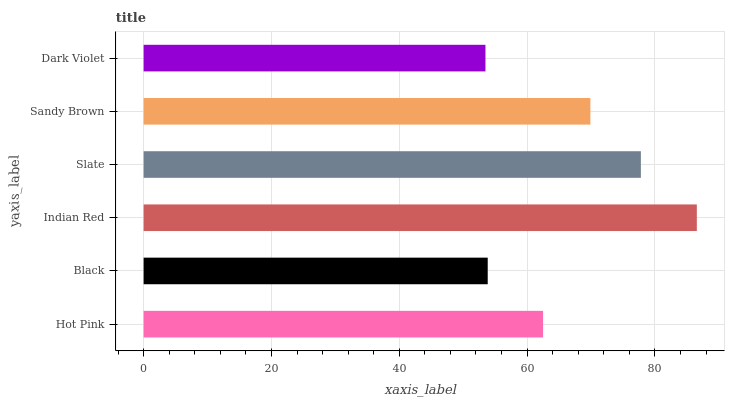Is Dark Violet the minimum?
Answer yes or no. Yes. Is Indian Red the maximum?
Answer yes or no. Yes. Is Black the minimum?
Answer yes or no. No. Is Black the maximum?
Answer yes or no. No. Is Hot Pink greater than Black?
Answer yes or no. Yes. Is Black less than Hot Pink?
Answer yes or no. Yes. Is Black greater than Hot Pink?
Answer yes or no. No. Is Hot Pink less than Black?
Answer yes or no. No. Is Sandy Brown the high median?
Answer yes or no. Yes. Is Hot Pink the low median?
Answer yes or no. Yes. Is Indian Red the high median?
Answer yes or no. No. Is Slate the low median?
Answer yes or no. No. 